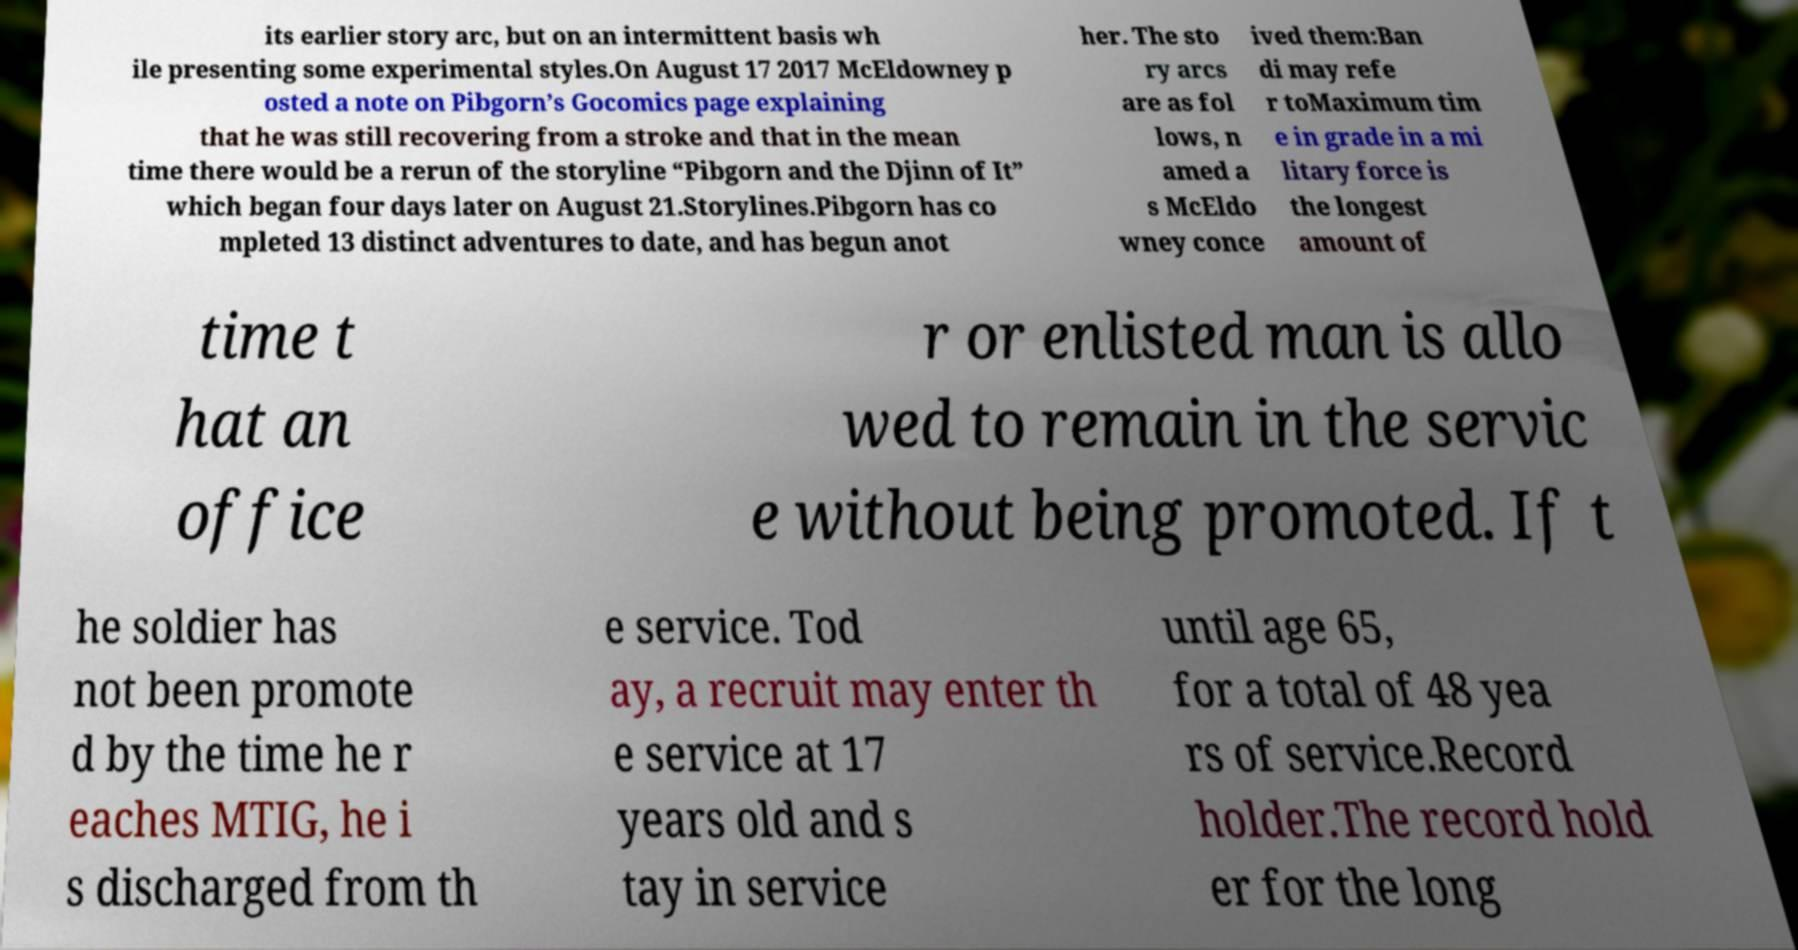Please identify and transcribe the text found in this image. its earlier story arc, but on an intermittent basis wh ile presenting some experimental styles.On August 17 2017 McEldowney p osted a note on Pibgorn’s Gocomics page explaining that he was still recovering from a stroke and that in the mean time there would be a rerun of the storyline “Pibgorn and the Djinn of It” which began four days later on August 21.Storylines.Pibgorn has co mpleted 13 distinct adventures to date, and has begun anot her. The sto ry arcs are as fol lows, n amed a s McEldo wney conce ived them:Ban di may refe r toMaximum tim e in grade in a mi litary force is the longest amount of time t hat an office r or enlisted man is allo wed to remain in the servic e without being promoted. If t he soldier has not been promote d by the time he r eaches MTIG, he i s discharged from th e service. Tod ay, a recruit may enter th e service at 17 years old and s tay in service until age 65, for a total of 48 yea rs of service.Record holder.The record hold er for the long 